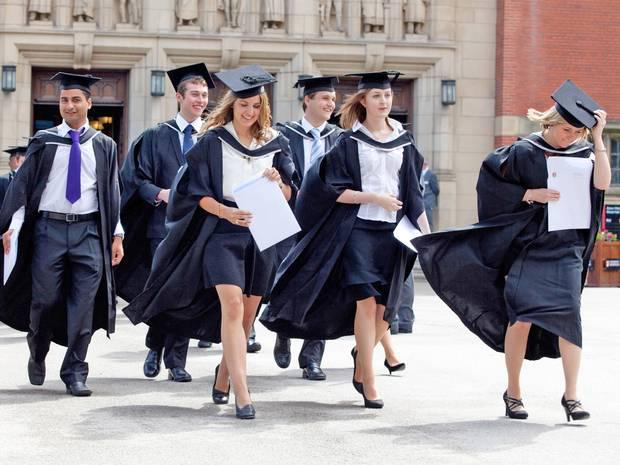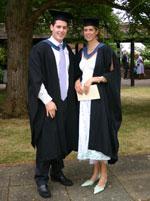The first image is the image on the left, the second image is the image on the right. Assess this claim about the two images: "One image shows one male graduate posing with one female in the foreground.". Correct or not? Answer yes or no. Yes. 